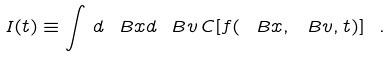<formula> <loc_0><loc_0><loc_500><loc_500>I ( t ) \equiv \int \, d \ B x d \ B v \, C [ f ( \ B x , \ B v , t ) ] \ .</formula> 